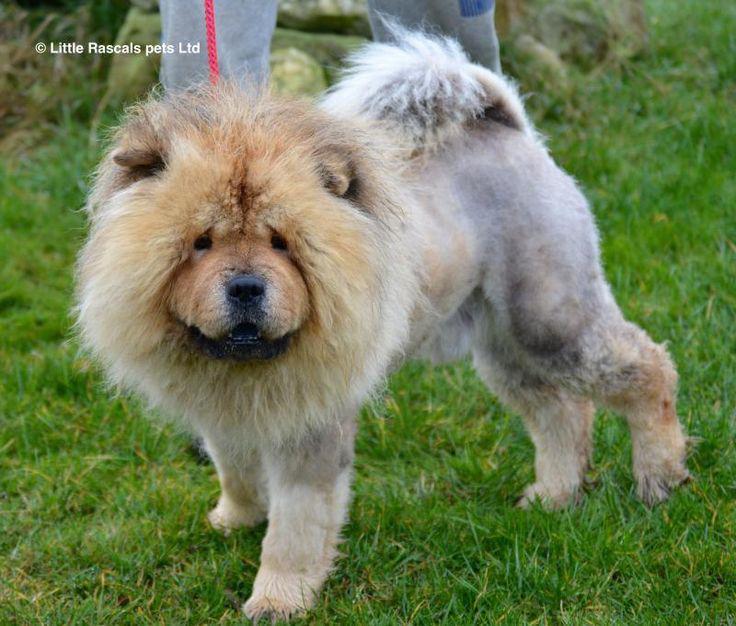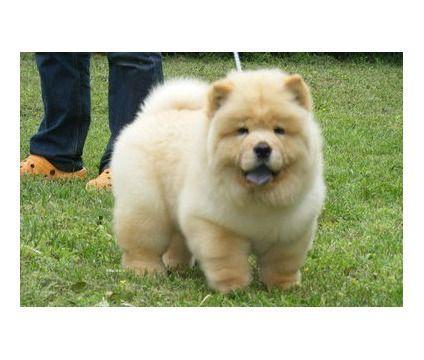The first image is the image on the left, the second image is the image on the right. Examine the images to the left and right. Is the description "There are at least two dogs in the image on the left." accurate? Answer yes or no. No. The first image is the image on the left, the second image is the image on the right. Considering the images on both sides, is "There are no less than three dogs" valid? Answer yes or no. No. 